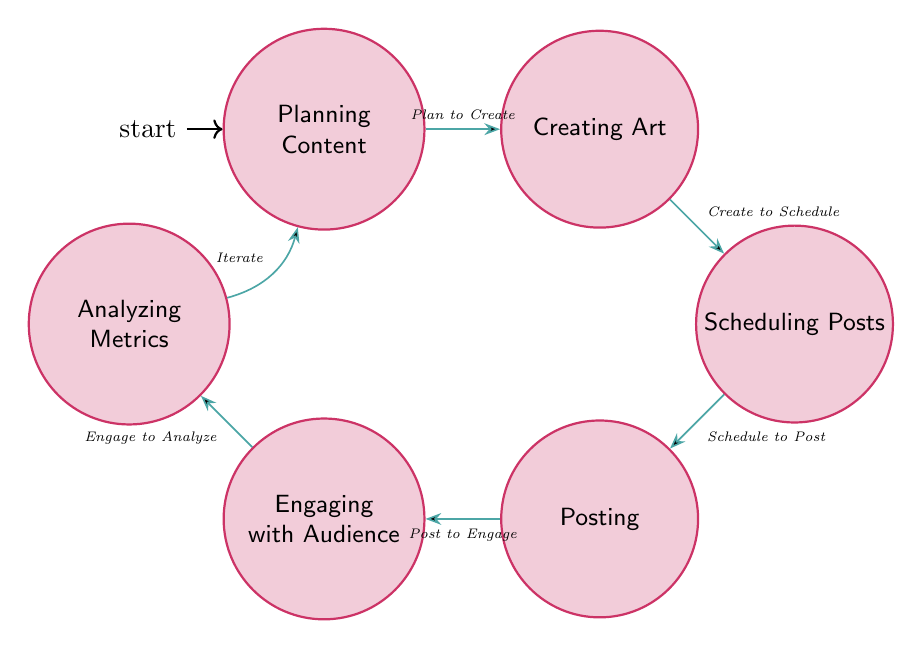What is the total number of nodes in the diagram? The diagram lists six distinct states: Planning Content, Creating Art, Scheduling Posts, Posting, Engaging with Audience, and Analyzing Metrics. Counting these states gives us a total of six nodes.
Answer: 6 What is the description of the node "Posting"? The node "Posting" is described as publishing the content on designated social media platforms. This can be found directly as the description connected to the "Posting" node.
Answer: Publishing the content on designated social media platforms What is the first transition from "Planning Content"? The first transition from "Planning Content" is labeled "Plan to Create," which indicates the movement from planning the content to creating the art. This label can be seen on the arrow connecting these two nodes.
Answer: Plan to Create What follows after "Engaging with Audience"? After "Engaging with Audience," the next action is "Analyzing Metrics," which is shown via the arrow leading from the Engaging Audience node. This indicates that this is the subsequent state after engaging with the audience.
Answer: Analyzing Metrics How many transitions are there in total in the diagram? There are five transitions visible in the diagram: Plan to Create, Create to Schedule, Schedule to Post, Post to Engage, and Engage to Analyze. Counting these gives a total of five transitions in the finite state machine.
Answer: 5 What happens after posting content according to the diagram? After posting content, the next action is to engage with the audience, which is stated in the transition "Post to Engage." This path illustrates the sequence of actions in the campaign.
Answer: Engaging with Audience Which node represents the initial state of the campaign? The initial state of the campaign is represented by the "Planning Content" node. It is marked as the starting point of the process according to the diagram’s notation of the initial state.
Answer: Planning Content If you are currently analyzing metrics, which node should you transition to next? If currently analyzing metrics, you should transition back to "Planning Content." The diagram indicates this with the "Iterate" transition labeled on the arrow bending back to the initial state.
Answer: Planning Content What is the last activity in this finite state machine? The last activity in the finite state machine is "Analyzing Metrics," as it is the final node reached before looping back to the planning stage. This is defined by the diagram layout and transitions.
Answer: Analyzing Metrics 